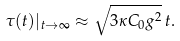Convert formula to latex. <formula><loc_0><loc_0><loc_500><loc_500>\tau ( t ) | _ { t \to \infty } \approx \sqrt { 3 \kappa C _ { 0 } g ^ { 2 } } \, t .</formula> 